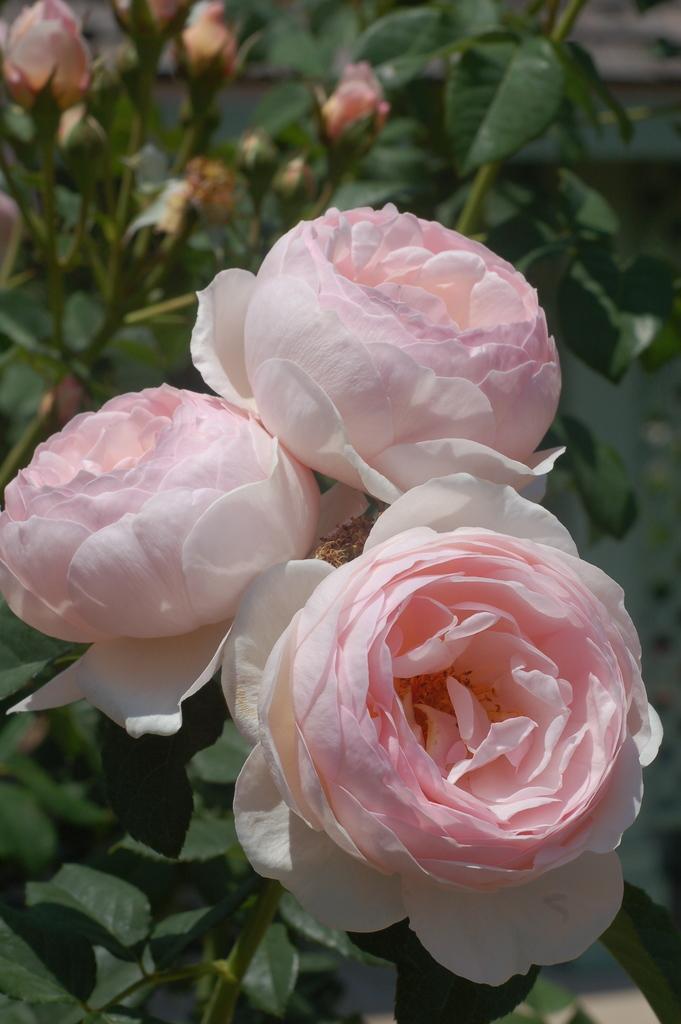In one or two sentences, can you explain what this image depicts? In this image, we can see rose flowers, stems and leaves. Background we can see blur view. Here we can see few flower buds, stems and leaves. 